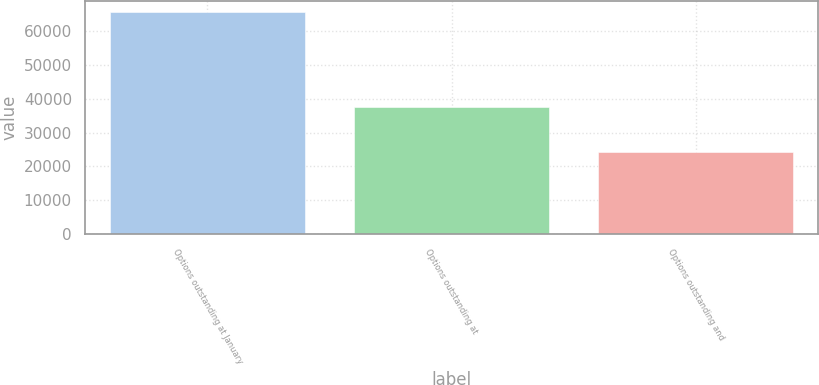Convert chart to OTSL. <chart><loc_0><loc_0><loc_500><loc_500><bar_chart><fcel>Options outstanding at January<fcel>Options outstanding at<fcel>Options outstanding and<nl><fcel>65531<fcel>37544.1<fcel>24108<nl></chart> 